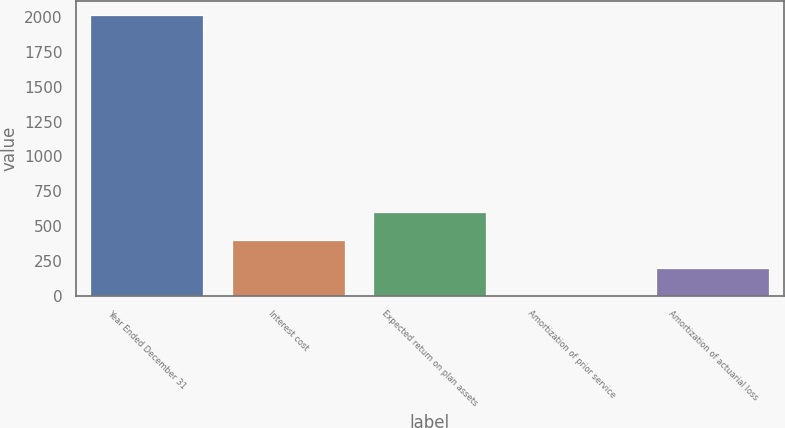Convert chart. <chart><loc_0><loc_0><loc_500><loc_500><bar_chart><fcel>Year Ended December 31<fcel>Interest cost<fcel>Expected return on plan assets<fcel>Amortization of prior service<fcel>Amortization of actuarial loss<nl><fcel>2012<fcel>404<fcel>605<fcel>2<fcel>203<nl></chart> 